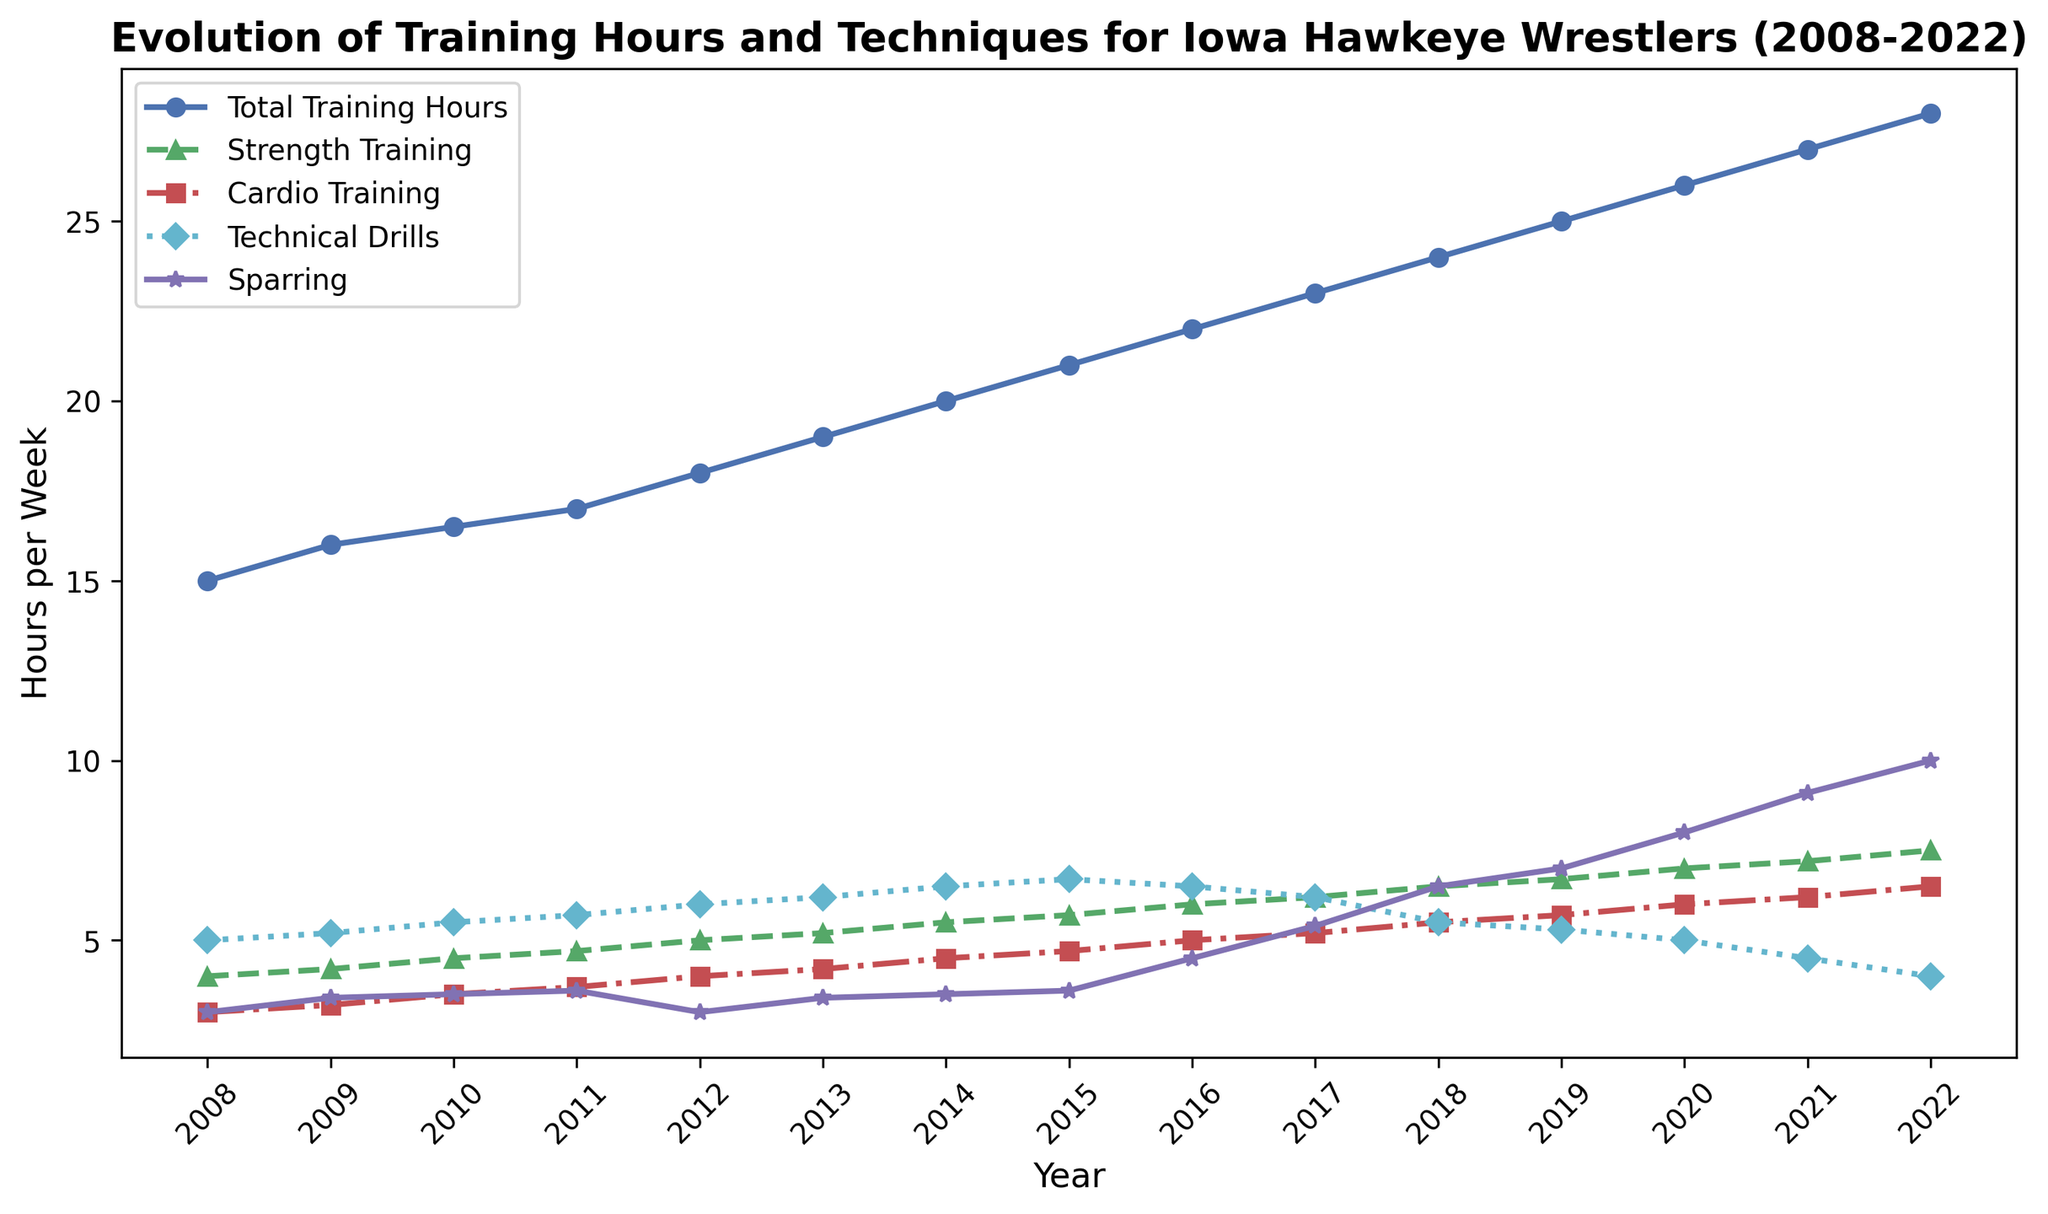What is the highest number of total training hours recorded in the given period? The plot line showing 'Total Training Hours' peaks at the year 2022. The y-axis value corresponding to this peak is 28 hours.
Answer: 28 hours In which year did sparring hours first surpass 7 hours per week? The sparring hours are shown by the magenta line with a star marker. The first year where it surpasses 7 hours is 2019.
Answer: 2019 How many more hours were dedicated to strength training in 2022 compared to 2008? The green line with a triangle marker in 2022 shows approximately 7.5 hours for strength training, and in 2008 it shows approximately 4 hours. So, 7.5 - 4 = 3.5 hours more in 2022.
Answer: 3.5 hours By how many hours did the total weekly training hours increase on average per year from 2008 to 2022? Total increase in hours from 2008 to 2022 is 28 - 15 = 13 hours over 14 years, so the average increase per year is 13 / 14 ≈ 0.93 hours.
Answer: 0.93 hours Which component of training showed a decrease from 2014 to 2022, and by how much? The cyan line with a diamond marker indicating 'Technical Drills' shows a decrease from roughly 6.5 hours in 2014 to about 4 hours in 2022. So, the decrease was 6.5 - 4 = 2.5 hours.
Answer: Technical Drills, 2.5 hours In which year was there an equal amount of time dedicated to cardio training and sparring? The year when the red line with a square marker intersects with the magenta line with a star marker is 2016. In this year, both cardio training and sparring were approximately 4.5 hours.
Answer: 2016 What visual trend is evident for strength training hours from 2008 to 2022? The green line with a triangle marker shows a consistent upward trend from about 4 hours in 2008 to around 7.5 hours in 2022.
Answer: Upward trend Which year had the smallest gap between strength training and technical drills? The smallest visual gap between the green line (strength training) and the cyan line (technical drills) appears around the year 2016.
Answer: 2016 What was the total number of hours spent on cardio training and sparring combined in 2020? The red line for cardio training shows 6 hours and the magenta line for sparring shows 8 hours in 2020. 6 + 8 = 14 hours.
Answer: 14 hours 